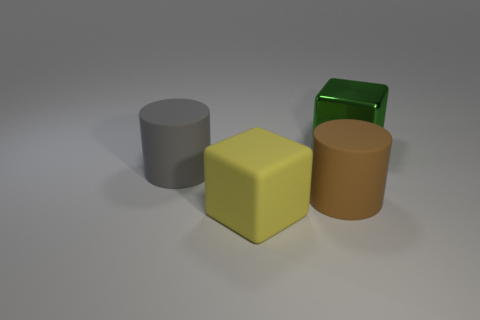What might be the purpose of setting up different colored objects like this? This setup of differently colored objects might be used for several purposes, such as illustrative teaching of colors and shapes in an educational context, visual composition studies in art and design, or lighting and texture analysis in a 3D modeling workshop. The distinct colors and simple shapes make it a versatile image for a variety of learning scenarios. 